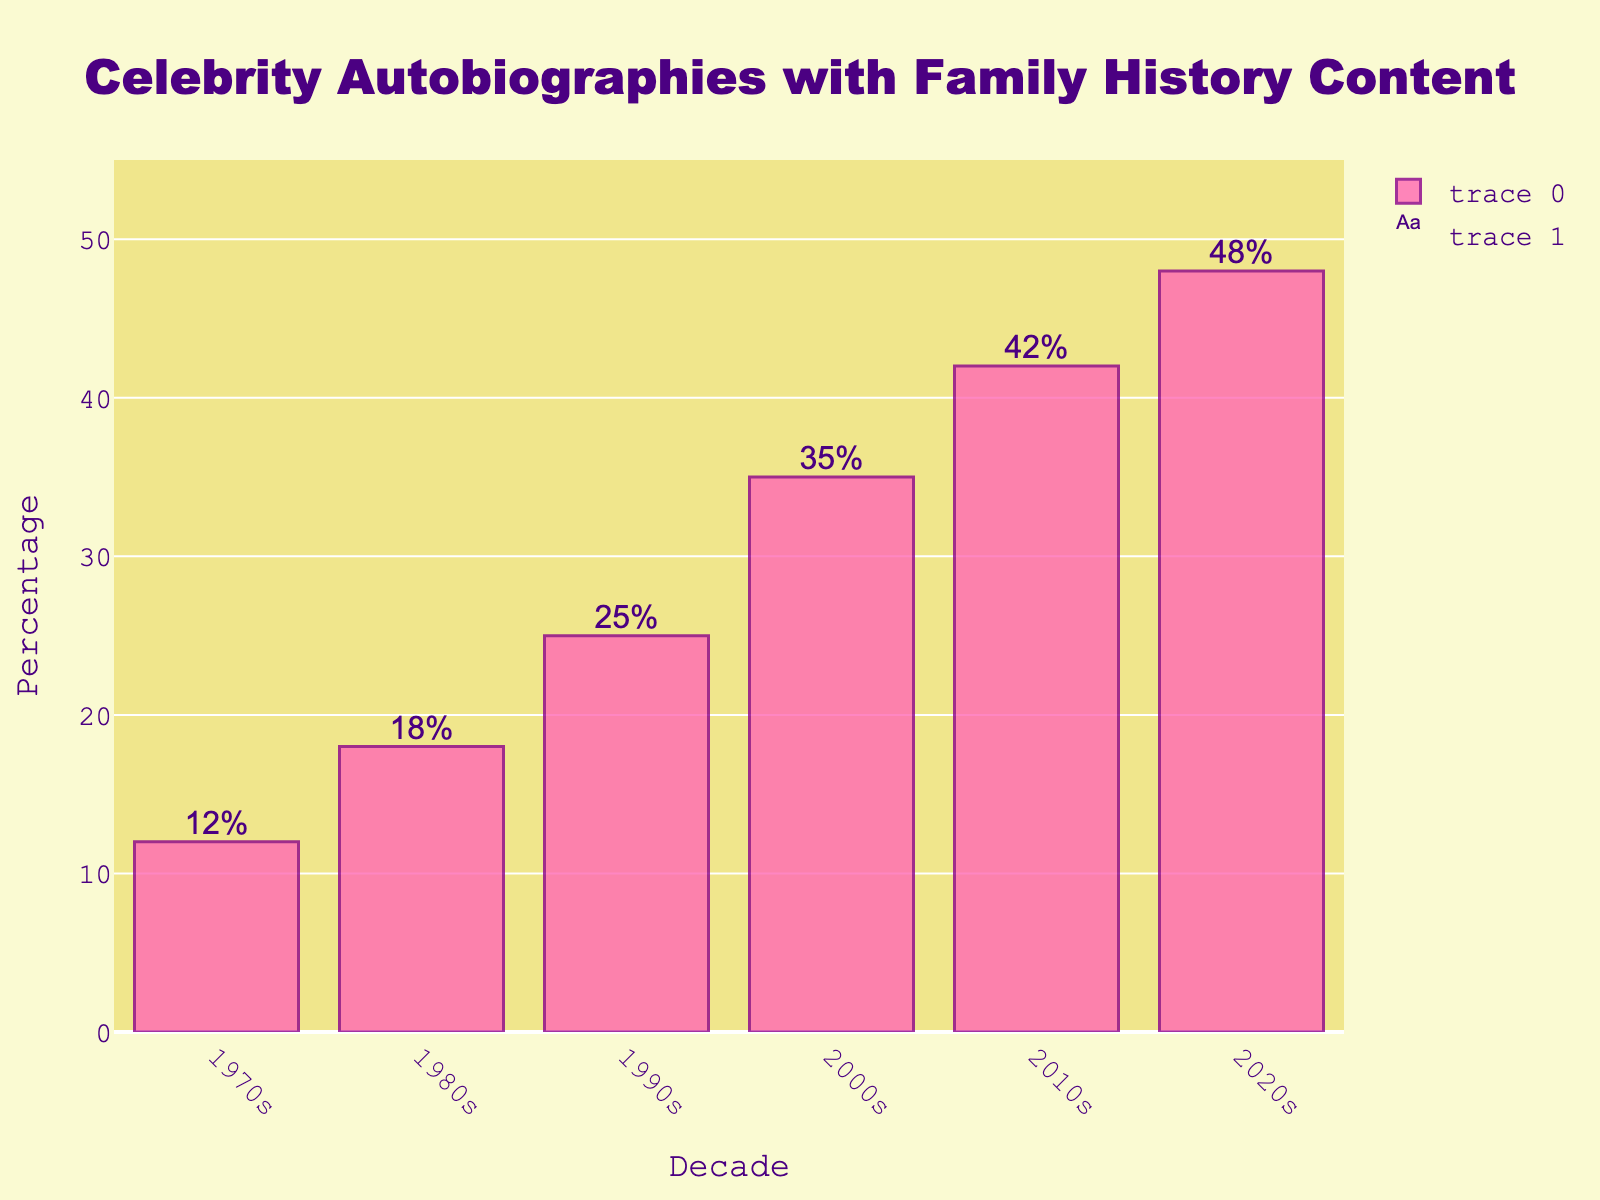What is the percentage of celebrity autobiographies featuring extensive family history content in the 1990s? Locate the bar for the 1990s on the x-axis and read the value at the top of the bar, which is labeled "25%".
Answer: 25% How much did the percentage of celebrity autobiographies featuring family history content increase from the 1970s to the 2020s? Subtract the percentage for the 1970s (12%) from the percentage for the 2020s (48%): 48% - 12% = 36%.
Answer: 36% Which decade saw the highest percentage of celebrity autobiographies with extensive family history content? Look for the bar with the greatest height; the 2020s have the highest bar with 48%.
Answer: 2020s What is the average percentage of celebrity autobiographies featuring extensive family history content from the 1970s to the 1990s? Add the percentages of the 1970s, 1980s, and 1990s (12% + 18% + 25%) and divide by 3: (12 + 18 + 25) / 3 = 18.33%.
Answer: 18.33% How does the percentage in the 2000s compare to that in the 2010s? Compare the height of the bars for the 2000s (35%) and the 2010s (42%). The bar for the 2010s is taller, indicating a higher percentage.
Answer: The percentage is higher in the 2010s Between which two consecutive decades is the largest increase in the percentage observed? Compare the differences between each consecutive decade: 
1980s - 1970s: 6% (18% - 12%)
1990s - 1980s: 7% (25% - 18%)
2000s - 1990s: 10% (35% - 25%)
2010s - 2000s: 7% (42% - 35%)
2020s - 2010s: 6% (48% - 42%)
The largest increase is between the 1990s and the 2000s with a 10% rise.
Answer: 1990s to 2000s What is the total percentage increase from 1970s to 2010s? Subtract the 1970s percentage (12%) from the 2010s percentage (42%): 42% - 12% = 30%.
Answer: 30% Compare the visual attributes of the bars for the 1980s and the 2010s. Which is taller and by how much? The bar for the 2010s (42%) is taller than the bar for the 1980s (18%). Calculate the difference: 42% - 18% = 24%.
Answer: The bar for the 2010s is taller by 24% 